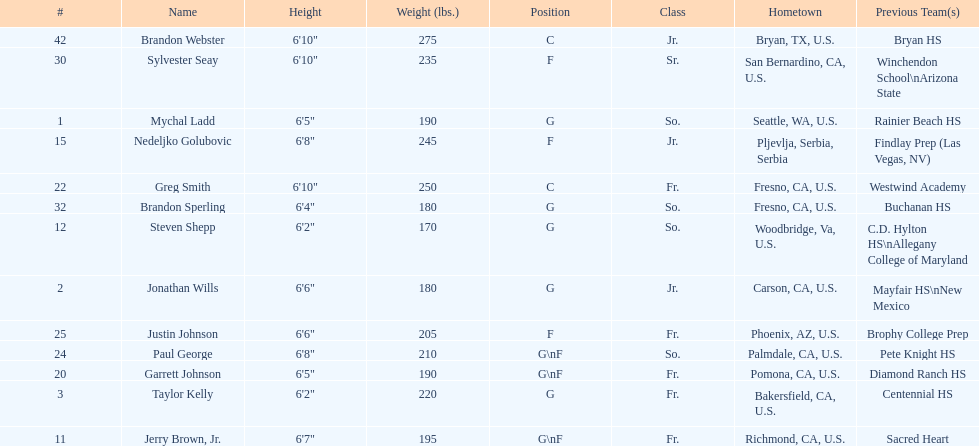Who weighs the most on the team? Brandon Webster. 